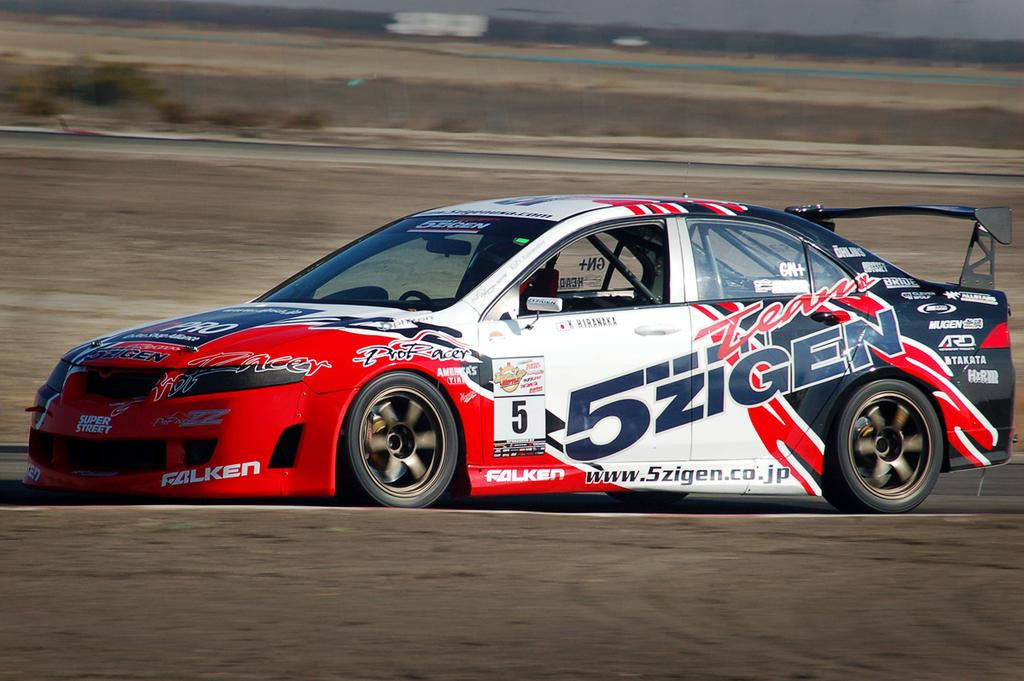What type of vehicle is in the center of the image? There is a sports car in the center of the image. What colors can be seen on the sports car? The sports car has white and red colors. Is there any text or writing on the sports car? Yes, there is writing on the sports car. What type of food is being prepared in the sports car? There is no food preparation happening in the sports car, as it is a vehicle and not a kitchen. 